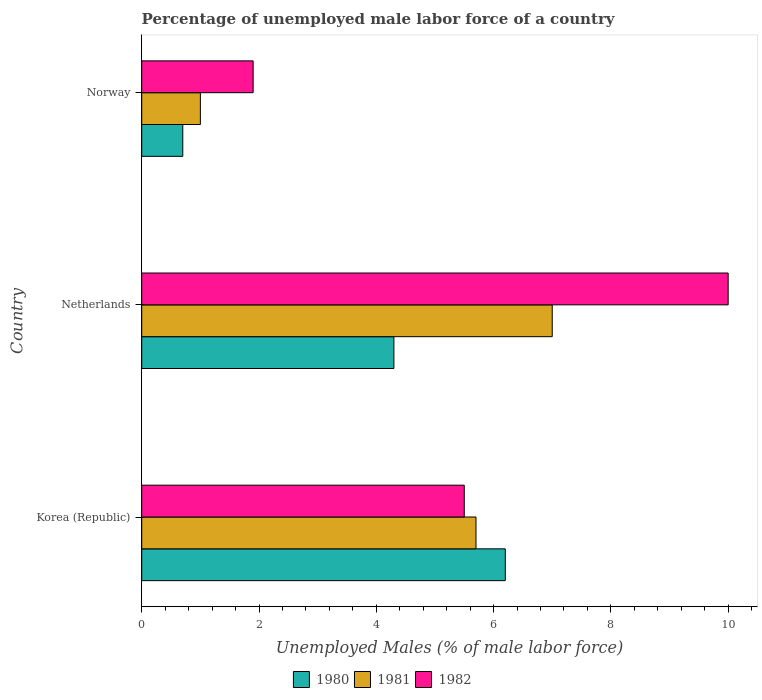How many groups of bars are there?
Give a very brief answer. 3. How many bars are there on the 1st tick from the top?
Make the answer very short. 3. How many bars are there on the 2nd tick from the bottom?
Your answer should be very brief. 3. What is the label of the 1st group of bars from the top?
Ensure brevity in your answer.  Norway. What is the percentage of unemployed male labor force in 1980 in Korea (Republic)?
Keep it short and to the point. 6.2. Across all countries, what is the maximum percentage of unemployed male labor force in 1982?
Provide a succinct answer. 10. Across all countries, what is the minimum percentage of unemployed male labor force in 1980?
Provide a short and direct response. 0.7. In which country was the percentage of unemployed male labor force in 1980 maximum?
Make the answer very short. Korea (Republic). What is the total percentage of unemployed male labor force in 1982 in the graph?
Your response must be concise. 17.4. What is the difference between the percentage of unemployed male labor force in 1981 in Korea (Republic) and that in Norway?
Your answer should be very brief. 4.7. What is the difference between the percentage of unemployed male labor force in 1982 in Netherlands and the percentage of unemployed male labor force in 1980 in Korea (Republic)?
Provide a succinct answer. 3.8. What is the average percentage of unemployed male labor force in 1980 per country?
Offer a very short reply. 3.73. In how many countries, is the percentage of unemployed male labor force in 1981 greater than 4.4 %?
Make the answer very short. 2. What is the ratio of the percentage of unemployed male labor force in 1980 in Korea (Republic) to that in Norway?
Make the answer very short. 8.86. Is the percentage of unemployed male labor force in 1982 in Korea (Republic) less than that in Netherlands?
Keep it short and to the point. Yes. Is the difference between the percentage of unemployed male labor force in 1981 in Korea (Republic) and Netherlands greater than the difference between the percentage of unemployed male labor force in 1982 in Korea (Republic) and Netherlands?
Give a very brief answer. Yes. What is the difference between the highest and the second highest percentage of unemployed male labor force in 1981?
Ensure brevity in your answer.  1.3. What is the difference between the highest and the lowest percentage of unemployed male labor force in 1982?
Keep it short and to the point. 8.1. Is it the case that in every country, the sum of the percentage of unemployed male labor force in 1980 and percentage of unemployed male labor force in 1982 is greater than the percentage of unemployed male labor force in 1981?
Your answer should be compact. Yes. How many bars are there?
Ensure brevity in your answer.  9. Are all the bars in the graph horizontal?
Your answer should be very brief. Yes. What is the difference between two consecutive major ticks on the X-axis?
Provide a short and direct response. 2. Does the graph contain any zero values?
Your response must be concise. No. Does the graph contain grids?
Offer a terse response. No. Where does the legend appear in the graph?
Your answer should be very brief. Bottom center. How many legend labels are there?
Give a very brief answer. 3. How are the legend labels stacked?
Make the answer very short. Horizontal. What is the title of the graph?
Your answer should be compact. Percentage of unemployed male labor force of a country. What is the label or title of the X-axis?
Your response must be concise. Unemployed Males (% of male labor force). What is the label or title of the Y-axis?
Your answer should be very brief. Country. What is the Unemployed Males (% of male labor force) in 1980 in Korea (Republic)?
Your answer should be very brief. 6.2. What is the Unemployed Males (% of male labor force) in 1981 in Korea (Republic)?
Provide a succinct answer. 5.7. What is the Unemployed Males (% of male labor force) of 1980 in Netherlands?
Provide a succinct answer. 4.3. What is the Unemployed Males (% of male labor force) in 1981 in Netherlands?
Your response must be concise. 7. What is the Unemployed Males (% of male labor force) of 1982 in Netherlands?
Ensure brevity in your answer.  10. What is the Unemployed Males (% of male labor force) of 1980 in Norway?
Your answer should be compact. 0.7. What is the Unemployed Males (% of male labor force) in 1982 in Norway?
Provide a short and direct response. 1.9. Across all countries, what is the maximum Unemployed Males (% of male labor force) in 1980?
Offer a terse response. 6.2. Across all countries, what is the maximum Unemployed Males (% of male labor force) of 1982?
Your response must be concise. 10. Across all countries, what is the minimum Unemployed Males (% of male labor force) in 1980?
Ensure brevity in your answer.  0.7. Across all countries, what is the minimum Unemployed Males (% of male labor force) of 1981?
Your answer should be very brief. 1. Across all countries, what is the minimum Unemployed Males (% of male labor force) of 1982?
Your response must be concise. 1.9. What is the total Unemployed Males (% of male labor force) in 1980 in the graph?
Make the answer very short. 11.2. What is the difference between the Unemployed Males (% of male labor force) of 1980 in Korea (Republic) and that in Netherlands?
Make the answer very short. 1.9. What is the difference between the Unemployed Males (% of male labor force) of 1981 in Korea (Republic) and that in Netherlands?
Your answer should be very brief. -1.3. What is the difference between the Unemployed Males (% of male labor force) in 1982 in Korea (Republic) and that in Netherlands?
Your response must be concise. -4.5. What is the difference between the Unemployed Males (% of male labor force) of 1980 in Korea (Republic) and that in Norway?
Your answer should be compact. 5.5. What is the difference between the Unemployed Males (% of male labor force) in 1981 in Netherlands and that in Norway?
Your answer should be very brief. 6. What is the difference between the Unemployed Males (% of male labor force) in 1982 in Netherlands and that in Norway?
Give a very brief answer. 8.1. What is the difference between the Unemployed Males (% of male labor force) in 1981 in Korea (Republic) and the Unemployed Males (% of male labor force) in 1982 in Norway?
Make the answer very short. 3.8. What is the difference between the Unemployed Males (% of male labor force) in 1980 in Netherlands and the Unemployed Males (% of male labor force) in 1981 in Norway?
Give a very brief answer. 3.3. What is the difference between the Unemployed Males (% of male labor force) in 1980 in Netherlands and the Unemployed Males (% of male labor force) in 1982 in Norway?
Ensure brevity in your answer.  2.4. What is the difference between the Unemployed Males (% of male labor force) in 1981 in Netherlands and the Unemployed Males (% of male labor force) in 1982 in Norway?
Offer a very short reply. 5.1. What is the average Unemployed Males (% of male labor force) in 1980 per country?
Keep it short and to the point. 3.73. What is the average Unemployed Males (% of male labor force) in 1981 per country?
Your answer should be very brief. 4.57. What is the difference between the Unemployed Males (% of male labor force) in 1980 and Unemployed Males (% of male labor force) in 1981 in Korea (Republic)?
Make the answer very short. 0.5. What is the difference between the Unemployed Males (% of male labor force) in 1980 and Unemployed Males (% of male labor force) in 1982 in Korea (Republic)?
Your answer should be very brief. 0.7. What is the difference between the Unemployed Males (% of male labor force) in 1981 and Unemployed Males (% of male labor force) in 1982 in Korea (Republic)?
Your response must be concise. 0.2. What is the difference between the Unemployed Males (% of male labor force) of 1981 and Unemployed Males (% of male labor force) of 1982 in Netherlands?
Your answer should be very brief. -3. What is the difference between the Unemployed Males (% of male labor force) of 1980 and Unemployed Males (% of male labor force) of 1981 in Norway?
Keep it short and to the point. -0.3. What is the difference between the Unemployed Males (% of male labor force) in 1981 and Unemployed Males (% of male labor force) in 1982 in Norway?
Provide a short and direct response. -0.9. What is the ratio of the Unemployed Males (% of male labor force) of 1980 in Korea (Republic) to that in Netherlands?
Make the answer very short. 1.44. What is the ratio of the Unemployed Males (% of male labor force) in 1981 in Korea (Republic) to that in Netherlands?
Make the answer very short. 0.81. What is the ratio of the Unemployed Males (% of male labor force) in 1982 in Korea (Republic) to that in Netherlands?
Give a very brief answer. 0.55. What is the ratio of the Unemployed Males (% of male labor force) of 1980 in Korea (Republic) to that in Norway?
Your answer should be compact. 8.86. What is the ratio of the Unemployed Males (% of male labor force) in 1982 in Korea (Republic) to that in Norway?
Make the answer very short. 2.89. What is the ratio of the Unemployed Males (% of male labor force) of 1980 in Netherlands to that in Norway?
Make the answer very short. 6.14. What is the ratio of the Unemployed Males (% of male labor force) of 1982 in Netherlands to that in Norway?
Provide a short and direct response. 5.26. What is the difference between the highest and the second highest Unemployed Males (% of male labor force) in 1980?
Your response must be concise. 1.9. What is the difference between the highest and the second highest Unemployed Males (% of male labor force) in 1981?
Keep it short and to the point. 1.3. What is the difference between the highest and the second highest Unemployed Males (% of male labor force) in 1982?
Provide a short and direct response. 4.5. What is the difference between the highest and the lowest Unemployed Males (% of male labor force) in 1980?
Your response must be concise. 5.5. What is the difference between the highest and the lowest Unemployed Males (% of male labor force) in 1982?
Provide a succinct answer. 8.1. 